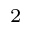<formula> <loc_0><loc_0><loc_500><loc_500>^ { 2 }</formula> 